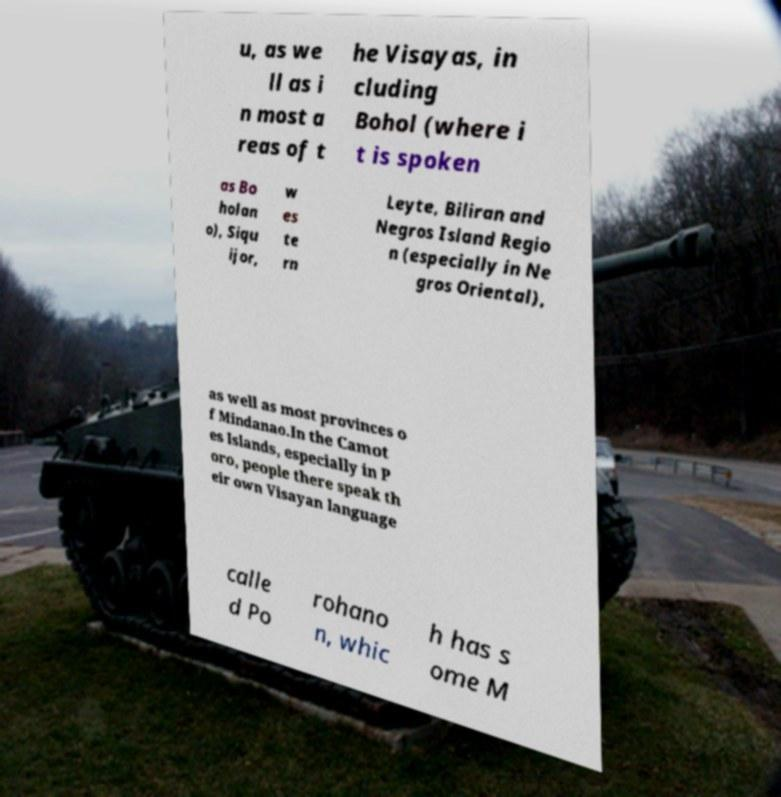What messages or text are displayed in this image? I need them in a readable, typed format. u, as we ll as i n most a reas of t he Visayas, in cluding Bohol (where i t is spoken as Bo holan o), Siqu ijor, w es te rn Leyte, Biliran and Negros Island Regio n (especially in Ne gros Oriental), as well as most provinces o f Mindanao.In the Camot es Islands, especially in P oro, people there speak th eir own Visayan language calle d Po rohano n, whic h has s ome M 